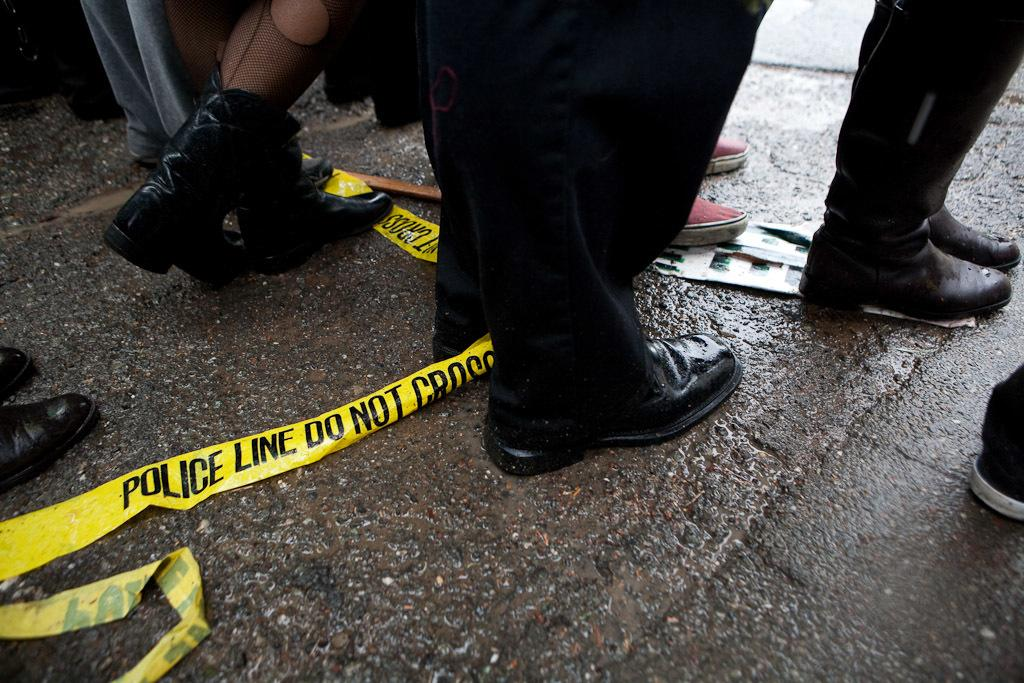What is visible in the image? There are persons' legs visible in the image. Where are the legs located? The legs are on the road. What type of beef can be seen being sold on the road in the image? There is no beef present in the image; it only features persons' legs on the road. What type of downtown area is depicted in the image? The image does not depict a downtown area; it only shows persons' legs on the road. 